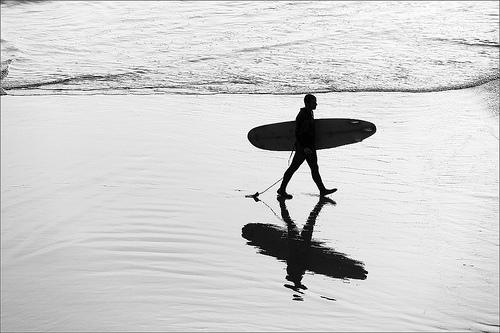From the image, can you determine which direction the man is walking? The man is walking to the right on the beach. Provide a brief summary of the image's key elements and the main action taking place. The image shows a man wearing a wetsuit, carrying a long surfboard with three fins, walking along a beach with wet sand, and a strap and rope dragging behind him. Describe any accessories or tools seen in the image. A strap and rope are dragging behind the man, possibly attached to his arm. What can be inferred about the water based on the image? The water is shallow and has ripples, with the reflection being rippled.  How would you depict the surfer's attire and demeanor in the image? The man is wearing a wetsuit and appears to be walking along the beach. Enumerate the key elements featured in the image. A man, surfboard, wet sand, water, wetsuit, reflection, strap, and rope. Please provide a short description of the surfboard's appearance. The surfboard is long and has three curved fins. Explain the state of the sand in the image. The sand is wet, covered in water, and has a man's shadow on it. Can you identify the main activity shown in the picture? A man is carrying a surfboard across the beach. Briefly describe the condition of the beach. The sand is wet and covered in water, with the tide going out. Describe the state of the tide in the image. The tide is going out. Determine the state of the sand in the image. The sand is wet with water. What type of hairstyle does the man have? The man has dark hair on his head. Can you see a man in the image without a wetsuit? The man is consistently described as wearing a wetsuit: "man is wearing wet suit X:283 Y:106 Width:39 Height:39", "person is wearing wetsuit X:282 Y:106 Width:40 Height:40", "man wearing a wetsuit X:285 Y:109 Width:41 Height:41". Create a multimodal description of the scene. A man in a wetsuit carries a long surfboard with three fins across a beach, as the tide goes back and cord drags behind him. The sand is wet, and shadows are cast on the beach while ripples and light reflections can be seen in the shallow ocean water. Where is the cord in the image originating from? The cord is dragging from the man's arm. What can you say about the tide in the image? The tide is going back, as water is washing back into the ocean and the sand is covered in water. Does the photo show a calm ocean with no visible ripples or waves? There are multiple references to ripples and waves in the image, such as "ripples in a shallow ocean water X:71 Y:223 Width:150 Height:150" and "small ocean wave on the beach X:18 Y:68 Width:464 Height:464". Which direction is the man walking in the image? The man is walking right on the beach. What is the general activity taking place in the image? A surfer is walking across the beach while carrying a surfboard. What is the man in the image doing? The man is walking on the beach while carrying a surfboard. Can you spot a surfer in the image sitting down, relaxing on the beach? The surfer in the image is described as walking or carrying a surfboard, such as "man carries surfboard across beach X:247 Y:95 Width:127 Height:127" and "surfer carrying surfboard along beach X:246 Y:91 Width:130 Height:130", not sitting or relaxing. Can you find some unique features on the surfboard? The surfboard has three curved fins. What type of outfit is the person in the image wearing?  The person is wearing a wetsuit. Describe the surfboard in the image. The surfboard is long, has three curved fins, and is being carried by a man along the beach. How would you describe the reflection in the water? The reflection is rippled in the water. What is happening with the strap and cord in the image? They are dragging behind the man carrying the surfboard. In the image, from the following options, which word best describes the ocean water? a) calm, b) rippled, c) stormy. rippled Describe the man's shadow on the beach. The man is silhouetted, and his shadow is cast on the wet sand. In the image, what is the man carrying across the beach? A surfboard. Does the man on the beach have short hair? The man in the image actually has "dark hair on a mans head X:302 Y:94 Width:13 Height:13", not short hair. Select the correct statement about the man's attire from the given options: 1) He is wearing a hat, 2) He is wearing a wetsuit, 3) He is wearing sunglasses. He is wearing a wetsuit. What can you infer about the ocean water in the image? There are ripples in the shallow water, and light is reflecting off of it. Is the surfboard in the image small and not very long? The surfboard is repeatedly described as "long" in the captions like "surfboard is long X:247 Y:117 Width:130 Height:130" and "the surfboard is long X:246 Y:116 Width:130 Height:130", contrary to the instruction. Is the beach in the image completely dry, without any water on it? There are numerous captions mentioning wet sand and water covering the beach, such as "sand is covered in water X:4 Y:92 Width:494 Height:494" and "sand is wet with water X:2 Y:93 Width:497 Height:497". 